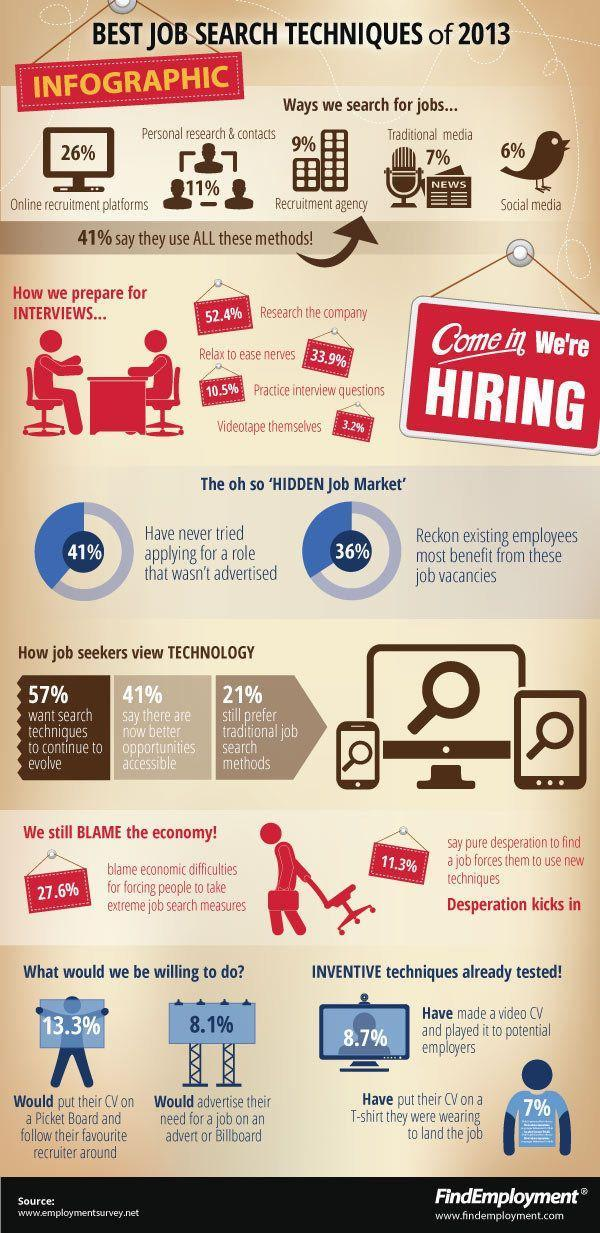What percent of people have tried applying for a role that wasn't advertised?
Answer the question with a short phrase. 59% What percentage of people advertised need for a job on billborad? 8.1% While preparing for interviews what do most people do? Research the company Which method is the best for job search? Online recruitmet platforms From where was this information taken? www.employmentsurvey.net 